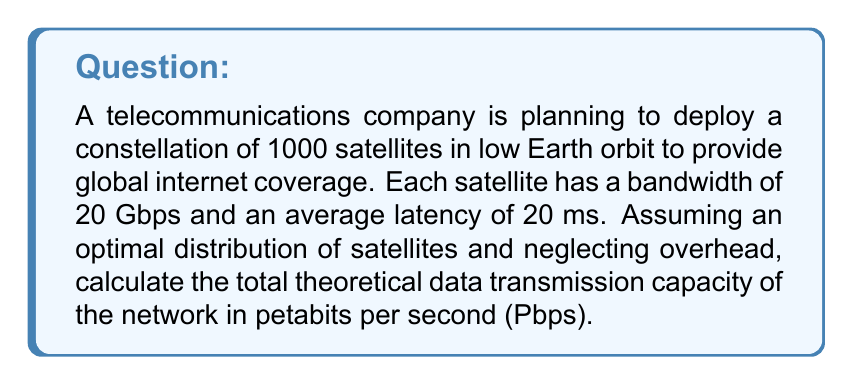Can you solve this math problem? To solve this problem, we need to follow these steps:

1. Calculate the data transmission capacity of a single satellite:
   The bandwidth of each satellite is 20 Gbps (gigabits per second).

2. Convert the bandwidth from Gbps to Pbps:
   $$ 20 \text{ Gbps} = 20 \times 10^{-3} \text{ Pbps} = 0.02 \text{ Pbps} $$

3. Calculate the total data transmission capacity of the network:
   Multiply the capacity of a single satellite by the total number of satellites.
   $$ \text{Total capacity} = 0.02 \text{ Pbps} \times 1000 \text{ satellites} = 20 \text{ Pbps} $$

4. Consider the effect of latency:
   In this case, the latency doesn't directly affect the total theoretical data transmission capacity. Latency would impact the time it takes for data to travel from source to destination, but not the amount of data that can be transmitted per unit time.

5. Final result:
   The total theoretical data transmission capacity of the network is 20 Pbps.

Note: This calculation assumes ideal conditions and doesn't account for factors such as interference, signal degradation, or network overhead. In real-world scenarios, the actual capacity would likely be lower due to these factors.
Answer: 20 Pbps (petabits per second) 